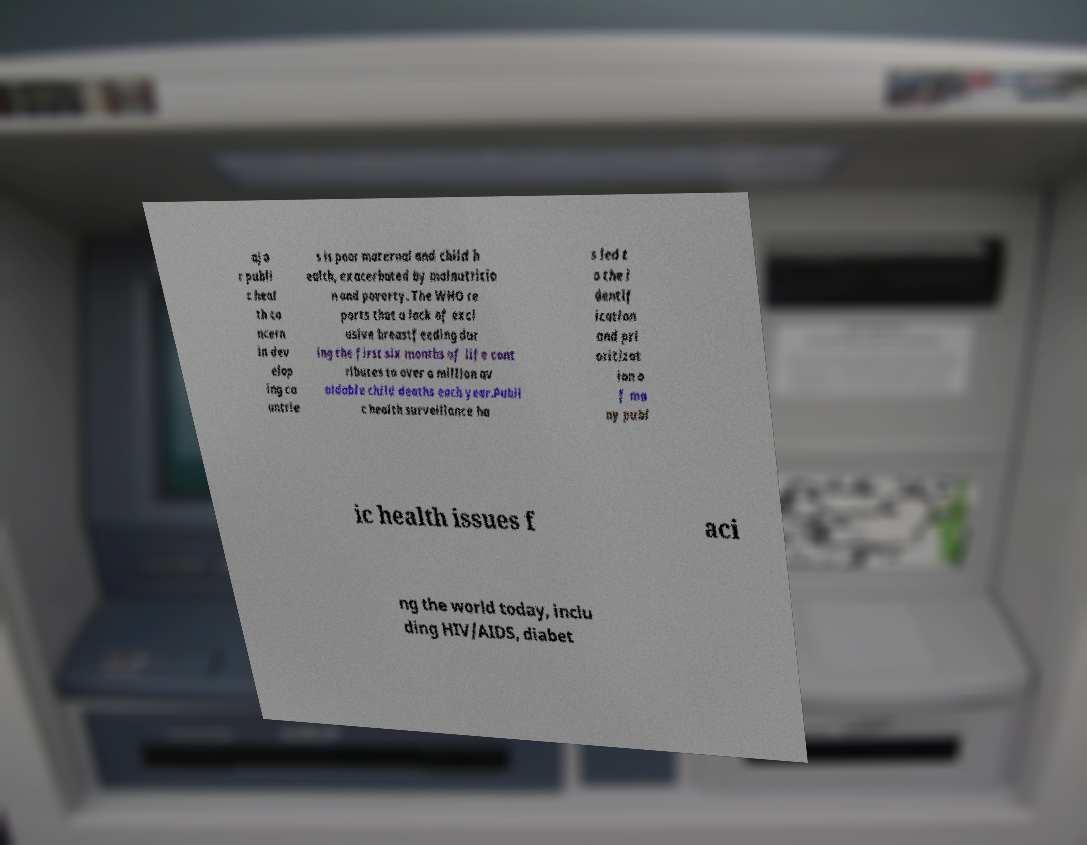What messages or text are displayed in this image? I need them in a readable, typed format. ajo r publi c heal th co ncern in dev elop ing co untrie s is poor maternal and child h ealth, exacerbated by malnutritio n and poverty. The WHO re ports that a lack of excl usive breastfeeding dur ing the first six months of life cont ributes to over a million av oidable child deaths each year.Publi c health surveillance ha s led t o the i dentif ication and pri oritizat ion o f ma ny publ ic health issues f aci ng the world today, inclu ding HIV/AIDS, diabet 